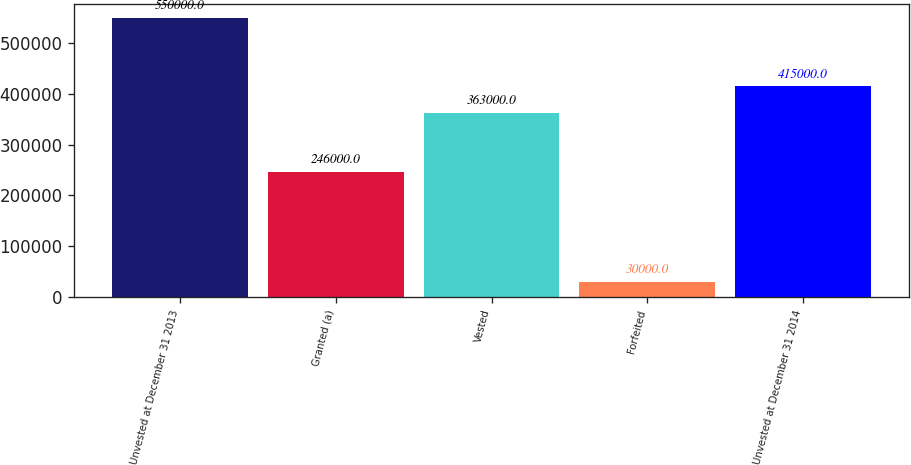Convert chart. <chart><loc_0><loc_0><loc_500><loc_500><bar_chart><fcel>Unvested at December 31 2013<fcel>Granted (a)<fcel>Vested<fcel>Forfeited<fcel>Unvested at December 31 2014<nl><fcel>550000<fcel>246000<fcel>363000<fcel>30000<fcel>415000<nl></chart> 